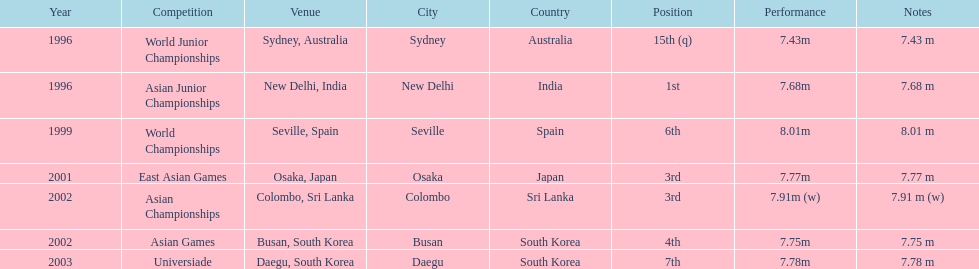What is the number of competitions that have been competed in? 7. 